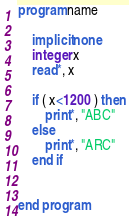Convert code to text. <code><loc_0><loc_0><loc_500><loc_500><_FORTRAN_>program name

    implicit none
    integer x
    read*, x

    if ( x<1200 ) then
        print*, "ABC"
    else
        print*, "ARC"
    end if


end program
</code> 